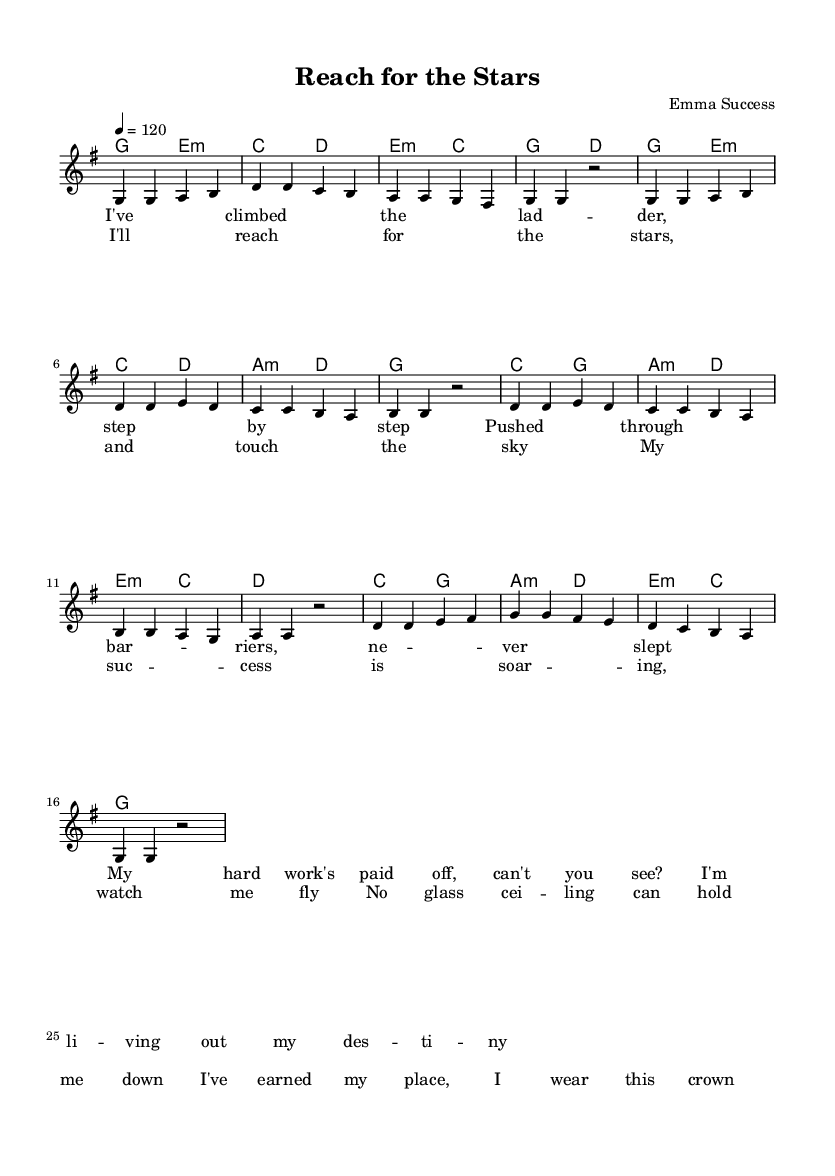What is the key signature of this music? The key signature indicates G major, which has one sharp (F#). This is evident from the `\key g \major` directive in the code.
Answer: G major What is the time signature of this music? The time signature shown is 4/4, which is indicated by the `\time 4/4` in the code. This means there are four beats per measure, and each quarter note gets one beat.
Answer: 4/4 What is the tempo of this music? The tempo is set at 120 beats per minute, as indicated by the `\tempo 4 = 120` line in the code. This suggests a moderately fast pace for the song.
Answer: 120 How many measures are in the chorus section? By counting the lines in the lyric section labeled as `\chorus`, we see there are four measures indicated by the grouping of lyrics. Each measure consists of a corresponding melodic line as well.
Answer: 4 What type of song structure is used in this piece? The piece follows a common pop song structure consisting of verses and a chorus. This is typical for pop anthems, where themes of empowerment and success are often repeated.
Answer: Verse-Chorus Which note starts the melody in the piece? The melody begins with the note G, as observed in the `\relative c'` section where the first note is shown. This sets the tone at the beginning of the piece.
Answer: G What theme is conveyed in the lyrics of this piece? The lyrics reflect themes of empowerment and overcoming obstacles, as indicated by lines like "I've climbed the ladder" and "I'll reach for the stars." This aligns with the portrayal of successful journeys in pop anthems.
Answer: Empowerment 